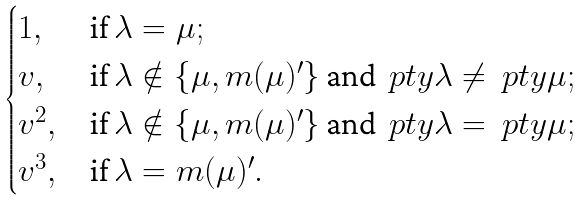<formula> <loc_0><loc_0><loc_500><loc_500>\begin{cases} 1 , & \text {if } \lambda = \mu ; \\ v , & \text {if } \lambda \notin \{ \mu , m ( \mu ) ^ { \prime } \} \text { and } \ p t y \lambda \ne \ p t y \mu ; \\ v ^ { 2 } , & \text {if } \lambda \notin \{ \mu , m ( \mu ) ^ { \prime } \} \text { and } \ p t y \lambda = \ p t y \mu ; \\ v ^ { 3 } , & \text {if } \lambda = m ( \mu ) ^ { \prime } . \end{cases}</formula> 